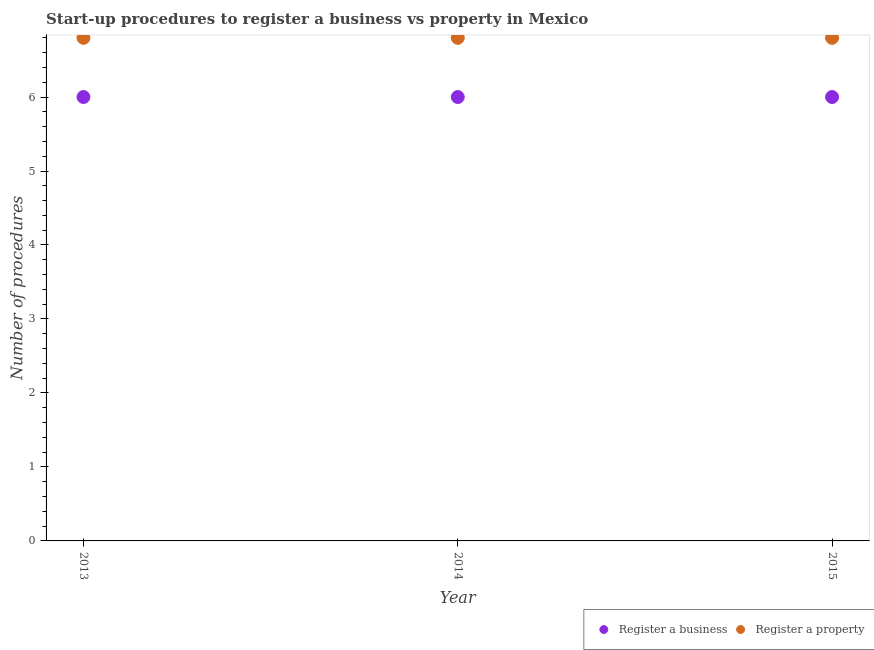Is the number of dotlines equal to the number of legend labels?
Your answer should be compact. Yes. What is the number of procedures to register a property in 2013?
Keep it short and to the point. 6.8. Across all years, what is the maximum number of procedures to register a business?
Make the answer very short. 6. Across all years, what is the minimum number of procedures to register a business?
Provide a succinct answer. 6. In which year was the number of procedures to register a property maximum?
Give a very brief answer. 2013. What is the total number of procedures to register a property in the graph?
Your response must be concise. 20.4. What is the difference between the number of procedures to register a business in 2013 and that in 2014?
Give a very brief answer. 0. What is the difference between the number of procedures to register a business in 2013 and the number of procedures to register a property in 2015?
Make the answer very short. -0.8. In the year 2015, what is the difference between the number of procedures to register a business and number of procedures to register a property?
Your answer should be very brief. -0.8. In how many years, is the number of procedures to register a business greater than 0.2?
Keep it short and to the point. 3. Is the number of procedures to register a business in 2013 less than that in 2014?
Your answer should be compact. No. Is the difference between the number of procedures to register a business in 2013 and 2015 greater than the difference between the number of procedures to register a property in 2013 and 2015?
Offer a very short reply. No. Is the sum of the number of procedures to register a business in 2013 and 2014 greater than the maximum number of procedures to register a property across all years?
Provide a succinct answer. Yes. Does the number of procedures to register a business monotonically increase over the years?
Ensure brevity in your answer.  No. Is the number of procedures to register a property strictly less than the number of procedures to register a business over the years?
Offer a terse response. No. How many dotlines are there?
Your answer should be very brief. 2. How many years are there in the graph?
Your answer should be very brief. 3. What is the difference between two consecutive major ticks on the Y-axis?
Ensure brevity in your answer.  1. Does the graph contain any zero values?
Give a very brief answer. No. How many legend labels are there?
Your answer should be compact. 2. How are the legend labels stacked?
Your answer should be compact. Horizontal. What is the title of the graph?
Your answer should be compact. Start-up procedures to register a business vs property in Mexico. What is the label or title of the Y-axis?
Provide a short and direct response. Number of procedures. What is the Number of procedures of Register a business in 2013?
Offer a very short reply. 6. What is the Number of procedures in Register a business in 2014?
Make the answer very short. 6. What is the Number of procedures in Register a property in 2014?
Ensure brevity in your answer.  6.8. What is the Number of procedures in Register a business in 2015?
Make the answer very short. 6. What is the Number of procedures of Register a property in 2015?
Make the answer very short. 6.8. Across all years, what is the minimum Number of procedures in Register a business?
Your response must be concise. 6. Across all years, what is the minimum Number of procedures in Register a property?
Keep it short and to the point. 6.8. What is the total Number of procedures in Register a property in the graph?
Your response must be concise. 20.4. What is the difference between the Number of procedures of Register a property in 2013 and that in 2014?
Your answer should be compact. 0. What is the difference between the Number of procedures in Register a business in 2013 and that in 2015?
Your answer should be compact. 0. What is the difference between the Number of procedures in Register a property in 2014 and that in 2015?
Ensure brevity in your answer.  0. What is the difference between the Number of procedures of Register a business in 2014 and the Number of procedures of Register a property in 2015?
Offer a terse response. -0.8. What is the average Number of procedures in Register a business per year?
Provide a succinct answer. 6. What is the average Number of procedures in Register a property per year?
Your answer should be very brief. 6.8. In the year 2014, what is the difference between the Number of procedures in Register a business and Number of procedures in Register a property?
Provide a short and direct response. -0.8. In the year 2015, what is the difference between the Number of procedures in Register a business and Number of procedures in Register a property?
Provide a short and direct response. -0.8. What is the ratio of the Number of procedures of Register a property in 2013 to that in 2015?
Ensure brevity in your answer.  1. What is the ratio of the Number of procedures in Register a property in 2014 to that in 2015?
Offer a very short reply. 1. What is the difference between the highest and the second highest Number of procedures in Register a business?
Offer a terse response. 0. 